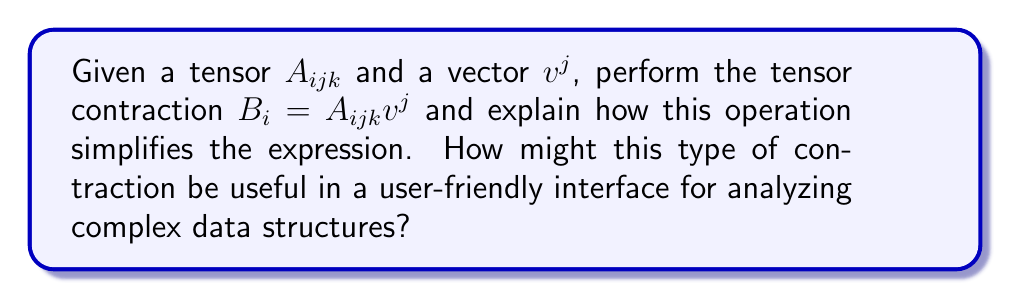Teach me how to tackle this problem. Let's break this down step-by-step:

1) Tensor contraction is an operation that reduces the rank of a tensor by summing over one or more index pairs. In this case, we're contracting the $j$ index.

2) The contraction $B_i = A_{ijk}v^j$ can be expanded as:

   $$B_i = \sum_j A_{ijk}v^j$$

3) This operation reduces the rank-3 tensor $A_{ijk}$ to a rank-1 tensor (vector) $B_i$.

4) The process can be visualized as:

   $A_{ijk}$ (3D array) $\rightarrow$ $B_i$ (1D array)

5) This simplification reduces the complexity of the expression and the amount of data to handle.

6) In a user-friendly interface, this type of contraction could be useful for:
   a) Data reduction: Simplifying complex multi-dimensional data into more manageable forms.
   b) Feature extraction: Identifying key characteristics in large datasets.
   c) Dimensionality reduction: Making high-dimensional data easier to visualize and analyze.

7) For example, in a data analysis tool, users could apply tensor contractions to compress complex datasets into simpler forms, making it easier to identify trends or patterns without needing to understand the underlying mathematical operations.
Answer: Tensor contraction $B_i = A_{ijk}v^j$ reduces tensor rank, simplifying data representation and analysis in user interfaces. 